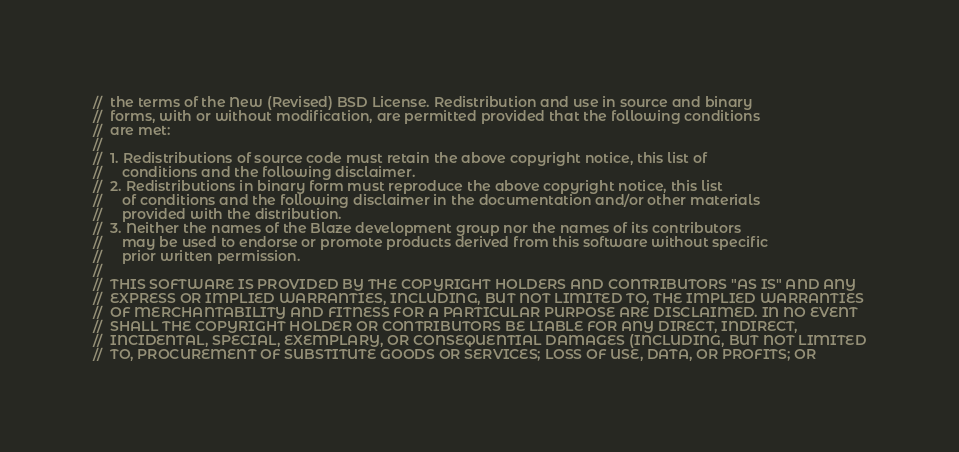Convert code to text. <code><loc_0><loc_0><loc_500><loc_500><_C_>//  the terms of the New (Revised) BSD License. Redistribution and use in source and binary
//  forms, with or without modification, are permitted provided that the following conditions
//  are met:
//
//  1. Redistributions of source code must retain the above copyright notice, this list of
//     conditions and the following disclaimer.
//  2. Redistributions in binary form must reproduce the above copyright notice, this list
//     of conditions and the following disclaimer in the documentation and/or other materials
//     provided with the distribution.
//  3. Neither the names of the Blaze development group nor the names of its contributors
//     may be used to endorse or promote products derived from this software without specific
//     prior written permission.
//
//  THIS SOFTWARE IS PROVIDED BY THE COPYRIGHT HOLDERS AND CONTRIBUTORS "AS IS" AND ANY
//  EXPRESS OR IMPLIED WARRANTIES, INCLUDING, BUT NOT LIMITED TO, THE IMPLIED WARRANTIES
//  OF MERCHANTABILITY AND FITNESS FOR A PARTICULAR PURPOSE ARE DISCLAIMED. IN NO EVENT
//  SHALL THE COPYRIGHT HOLDER OR CONTRIBUTORS BE LIABLE FOR ANY DIRECT, INDIRECT,
//  INCIDENTAL, SPECIAL, EXEMPLARY, OR CONSEQUENTIAL DAMAGES (INCLUDING, BUT NOT LIMITED
//  TO, PROCUREMENT OF SUBSTITUTE GOODS OR SERVICES; LOSS OF USE, DATA, OR PROFITS; OR</code> 